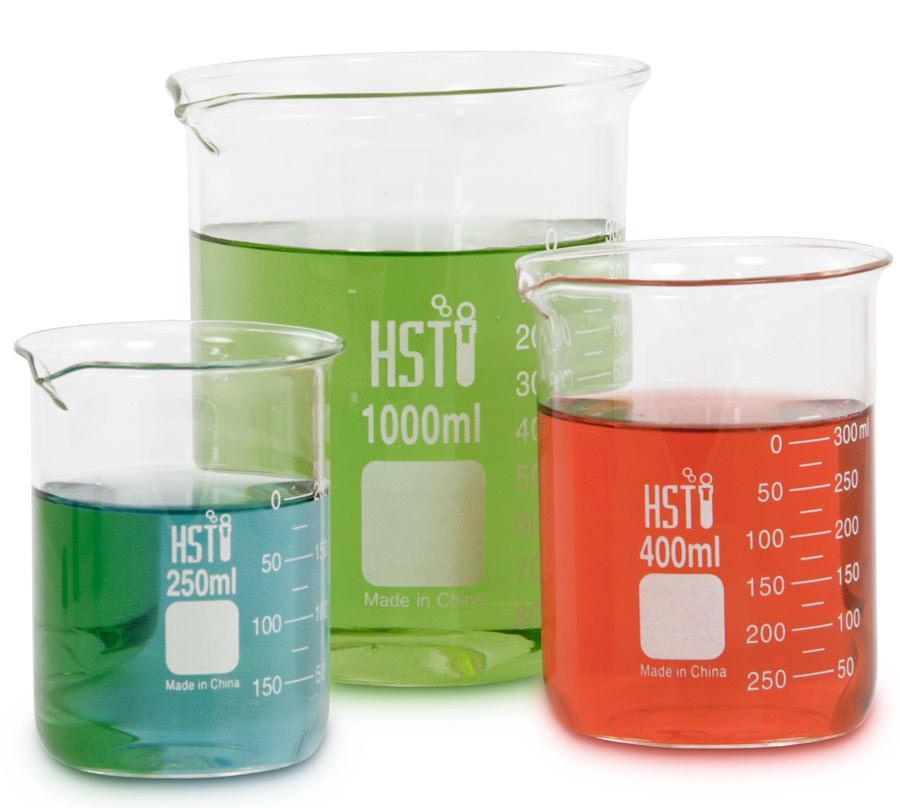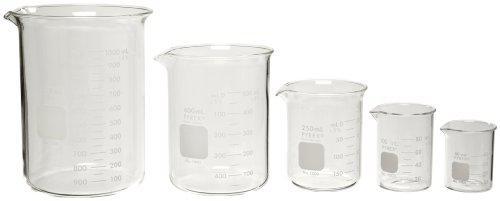The first image is the image on the left, the second image is the image on the right. Examine the images to the left and right. Is the description "The left and right image contains a total of eight beakers." accurate? Answer yes or no. Yes. The first image is the image on the left, the second image is the image on the right. For the images displayed, is the sentence "At least 7 beakers of varying sizes are filled with colorful liquid." factually correct? Answer yes or no. No. 